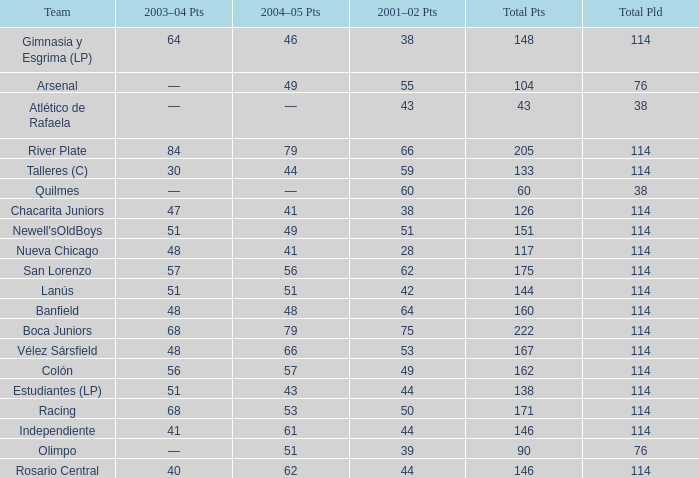Which Team has a Total Pld smaller than 114, and a 2004–05 Pts of 49? Arsenal. 